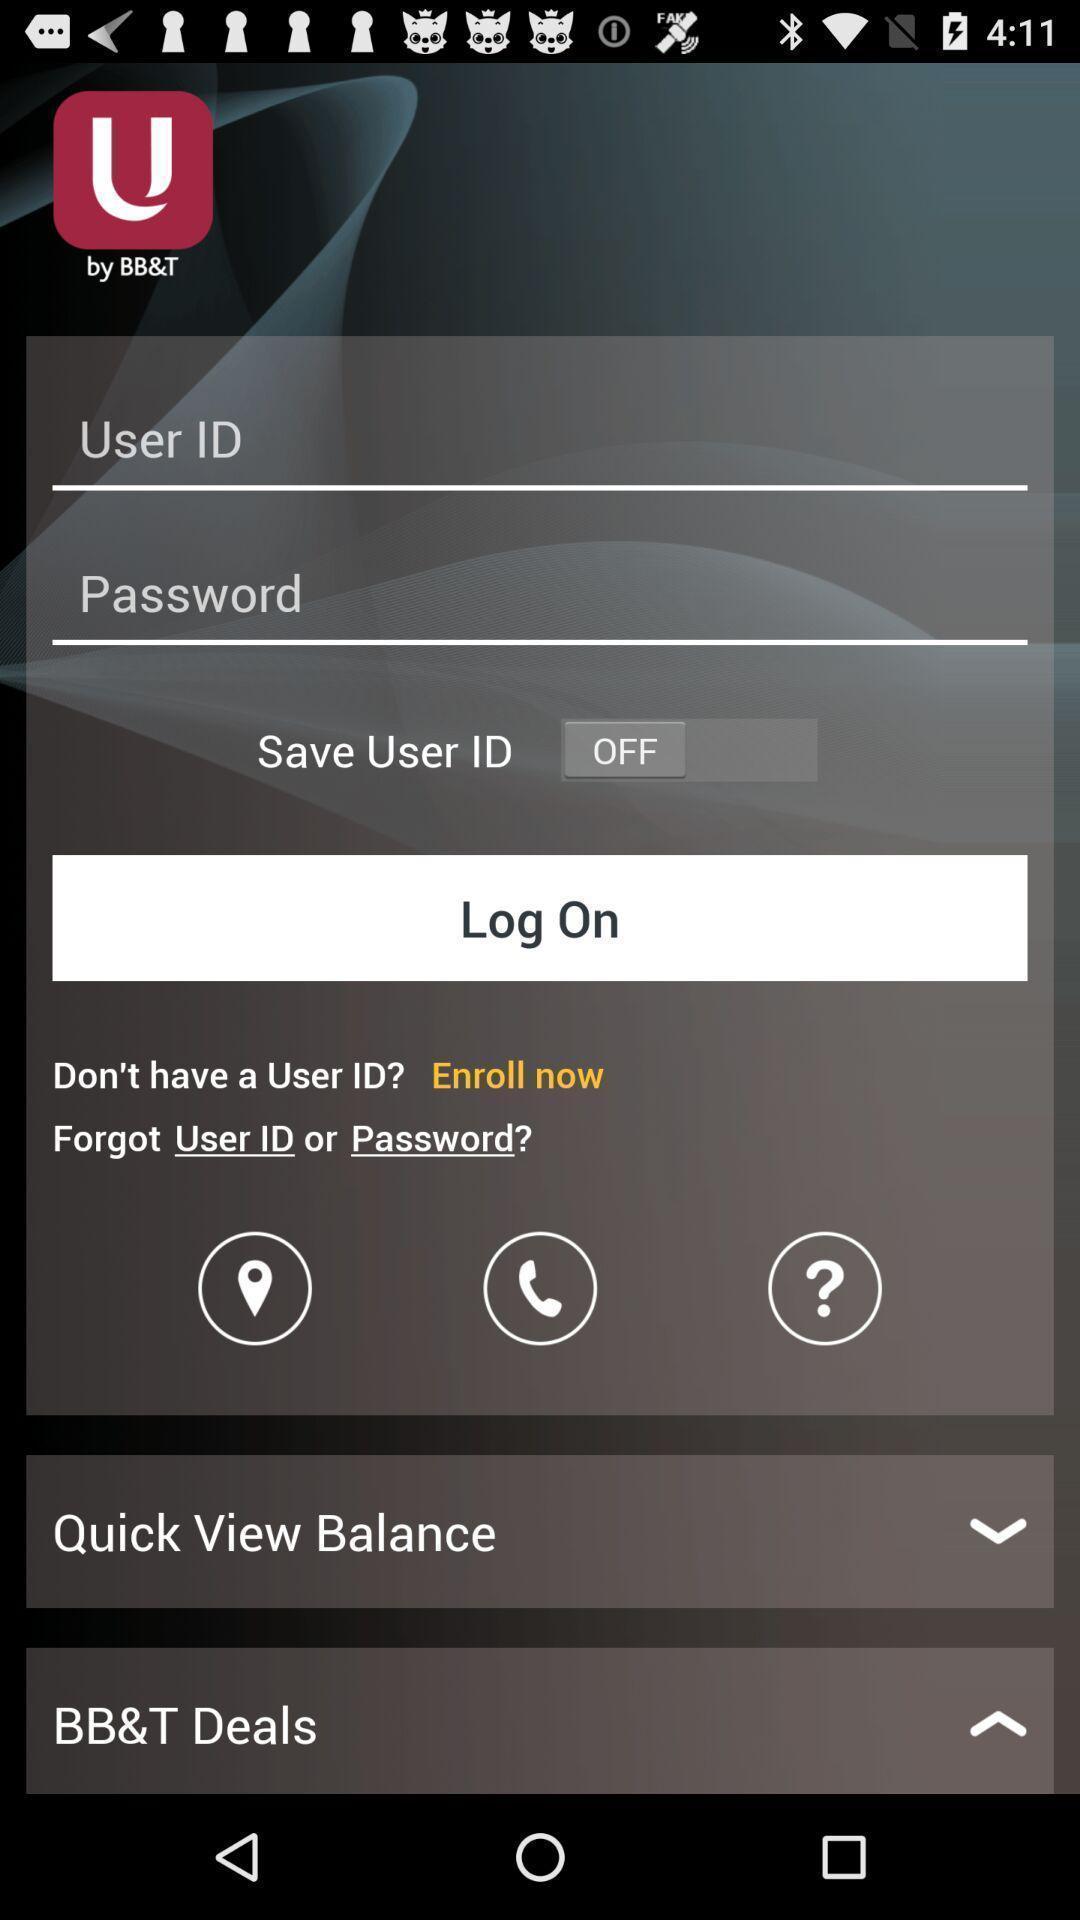Explain the elements present in this screenshot. Welcome page for mobile banking app. 